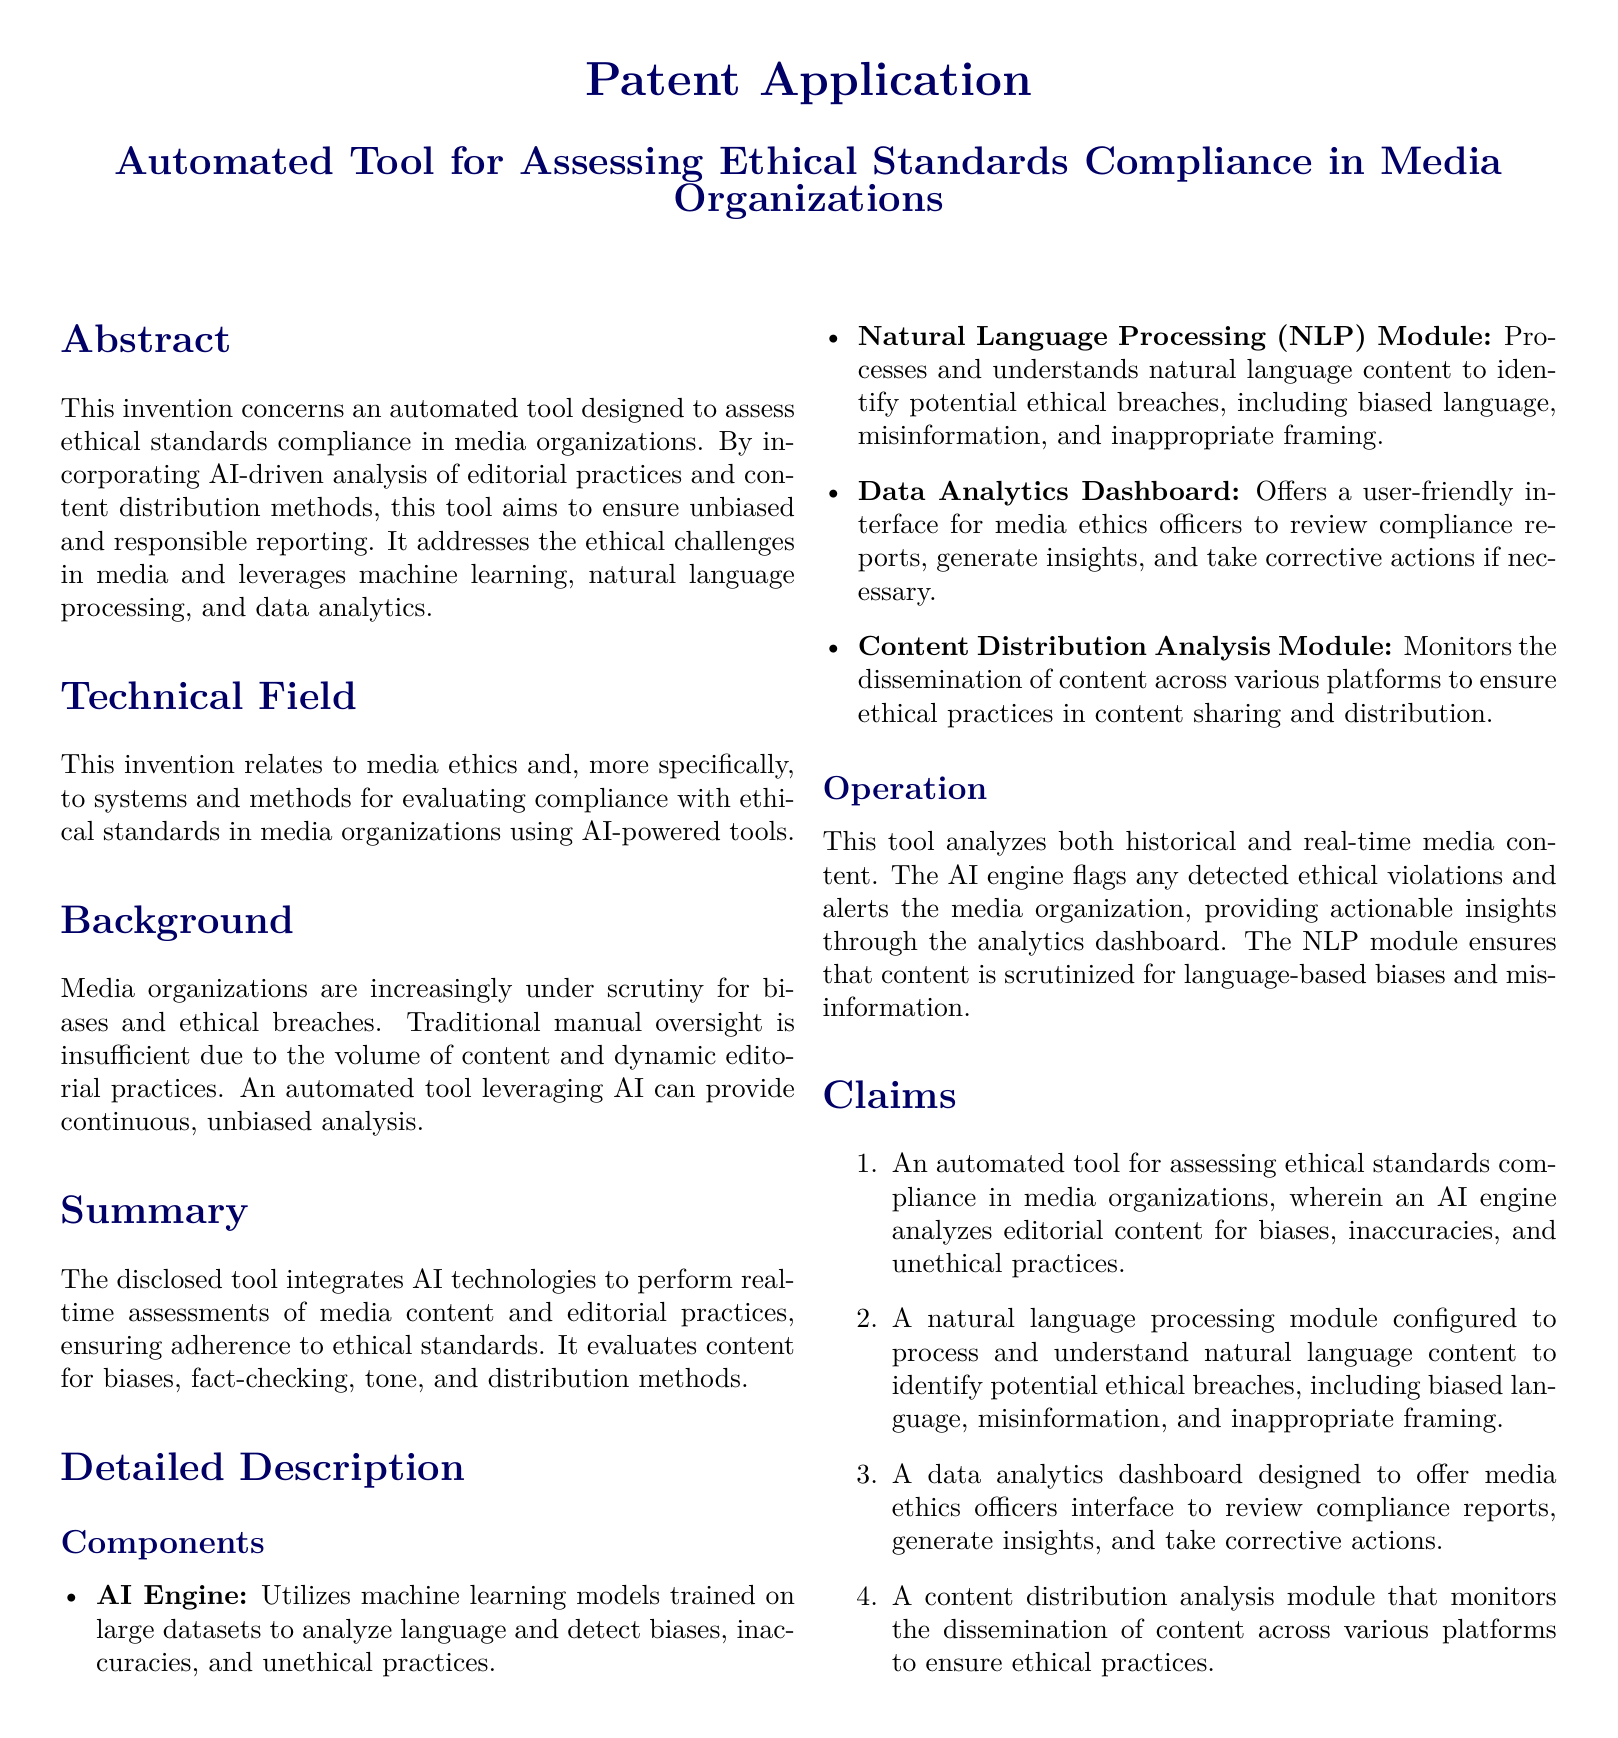What is the main purpose of the invention? The invention seeks to assess ethical standards compliance in media organizations through an automated tool.
Answer: Assess ethical standards compliance in media organizations What technology does the AI engine utilize? The AI engine utilizes machine learning models trained on large datasets for analysis.
Answer: Machine learning models What type of module is designed to process natural language? The natural language processing module is specifically designed for this purpose.
Answer: Natural language processing module How does the tool notify media organizations of ethical violations? The tool flags detected ethical violations and alerts the media organization.
Answer: Flags and alerts What does the data analytics dashboard provide? The dashboard provides a user-friendly interface for media ethics officers to review compliance reports.
Answer: User-friendly interface for compliance reports What is a key ethical issue the tool aims to address? The tool aims to address biases and inaccuracies in media editorial practices.
Answer: Biases and inaccuracies How many claims are made in the document? The document includes a total of four claims regarding the invention.
Answer: Four claims What is the primary function of the content distribution analysis module? The module monitors the dissemination of content across various platforms.
Answer: Monitors dissemination of content In what field does this invention relate? The invention relates to media ethics.
Answer: Media ethics 